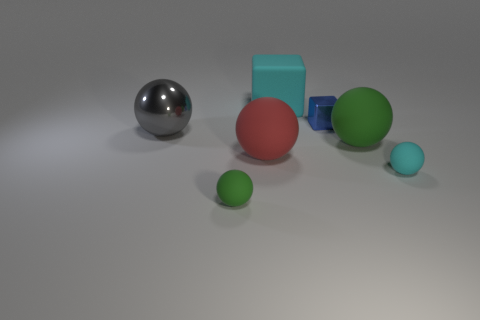There is a matte object that is the same color as the rubber block; what is its size?
Provide a short and direct response. Small. Is the small metallic object the same color as the big matte cube?
Give a very brief answer. No. What is the shape of the blue metal thing?
Your answer should be compact. Cube. Are there any small matte things of the same color as the big cube?
Keep it short and to the point. Yes. Is the number of gray metal spheres that are right of the small blue block greater than the number of small green spheres?
Ensure brevity in your answer.  No. There is a big cyan rubber object; is its shape the same as the metallic thing that is left of the red thing?
Your answer should be very brief. No. Is there a tiny yellow block?
Your answer should be compact. No. What number of small things are either brown metallic spheres or gray metallic balls?
Provide a short and direct response. 0. Are there more red rubber objects that are behind the large shiny object than tiny green rubber things that are behind the cyan matte block?
Ensure brevity in your answer.  No. Is the gray ball made of the same material as the cyan object that is in front of the large rubber cube?
Ensure brevity in your answer.  No. 